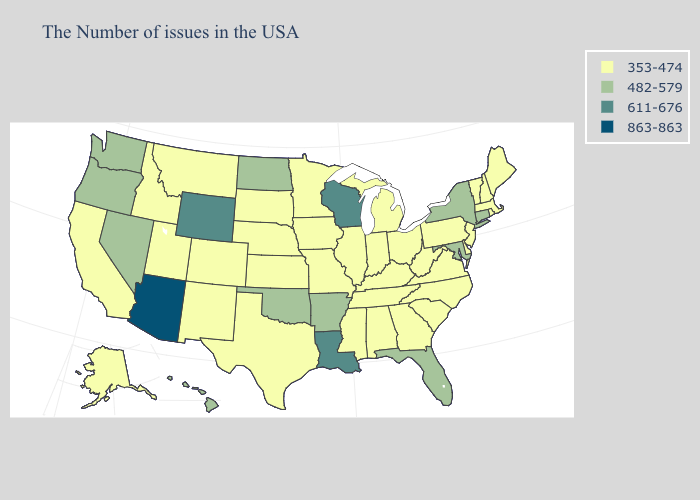What is the value of Florida?
Give a very brief answer. 482-579. Name the states that have a value in the range 863-863?
Give a very brief answer. Arizona. Name the states that have a value in the range 611-676?
Keep it brief. Wisconsin, Louisiana, Wyoming. What is the value of Washington?
Keep it brief. 482-579. Name the states that have a value in the range 353-474?
Be succinct. Maine, Massachusetts, Rhode Island, New Hampshire, Vermont, New Jersey, Delaware, Pennsylvania, Virginia, North Carolina, South Carolina, West Virginia, Ohio, Georgia, Michigan, Kentucky, Indiana, Alabama, Tennessee, Illinois, Mississippi, Missouri, Minnesota, Iowa, Kansas, Nebraska, Texas, South Dakota, Colorado, New Mexico, Utah, Montana, Idaho, California, Alaska. Does Virginia have the same value as Connecticut?
Keep it brief. No. What is the value of South Dakota?
Short answer required. 353-474. How many symbols are there in the legend?
Give a very brief answer. 4. Which states hav the highest value in the South?
Short answer required. Louisiana. Name the states that have a value in the range 863-863?
Concise answer only. Arizona. Name the states that have a value in the range 611-676?
Keep it brief. Wisconsin, Louisiana, Wyoming. Among the states that border Michigan , does Ohio have the highest value?
Give a very brief answer. No. Which states have the highest value in the USA?
Short answer required. Arizona. Does the first symbol in the legend represent the smallest category?
Write a very short answer. Yes. What is the value of Vermont?
Answer briefly. 353-474. 